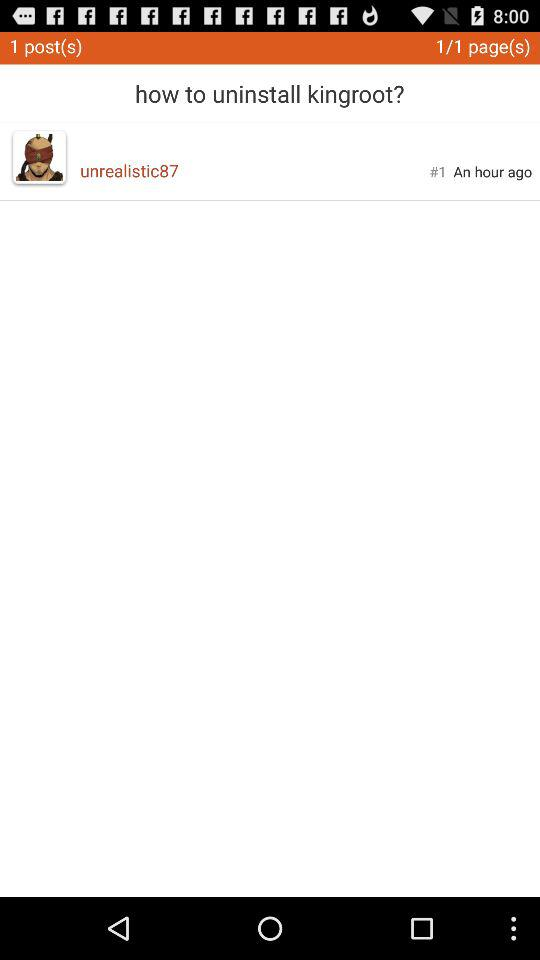When was the user last active? The user was last active one hour ago. 